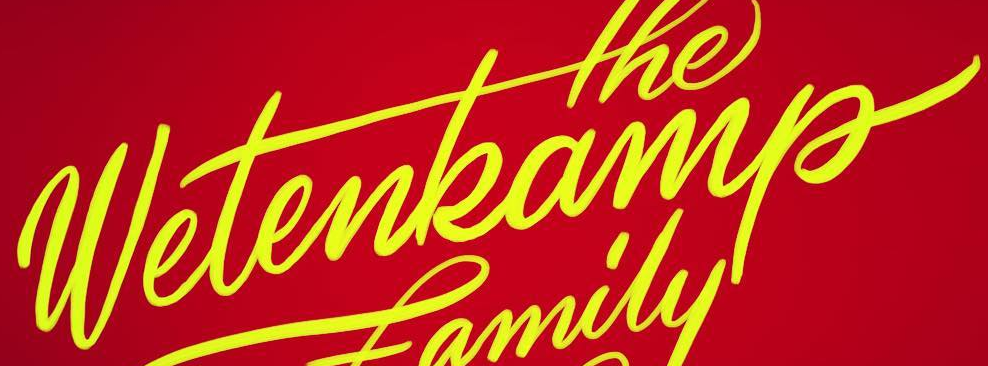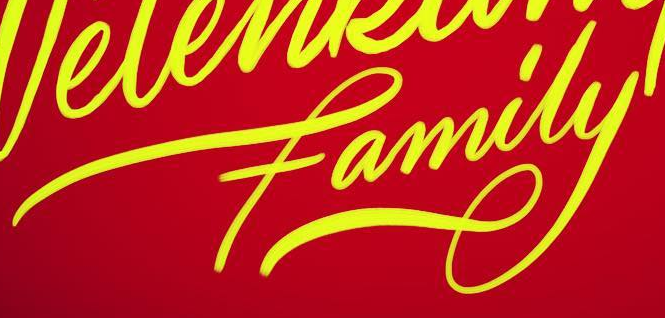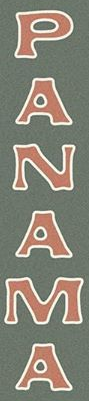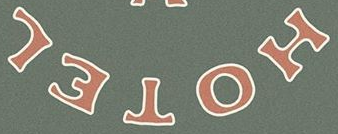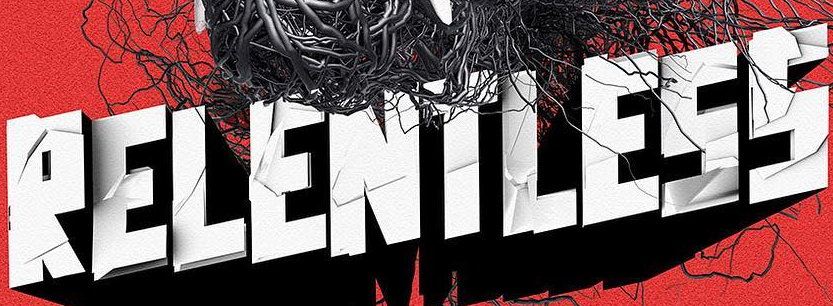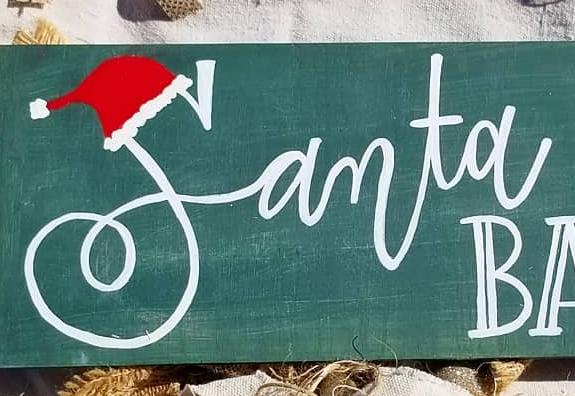Read the text from these images in sequence, separated by a semicolon. wetenkamp; family; PANAMA; HOTEL; RELENTLESS; Samta 